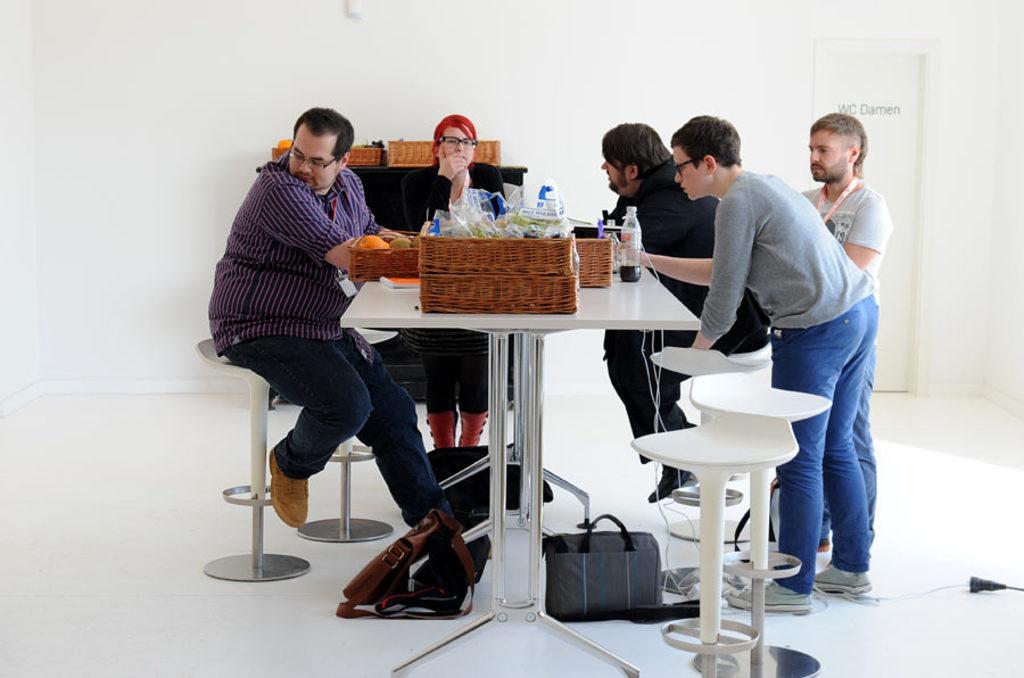In one or two sentences, can you explain what this image depicts? These three people sitting on chairs and these two people standing. We can see bottle, baskets, covers, fruits, book and objects on the table. We can see chairs and bags on the floor. In the background we can see baskets on the table, white wall and door. 